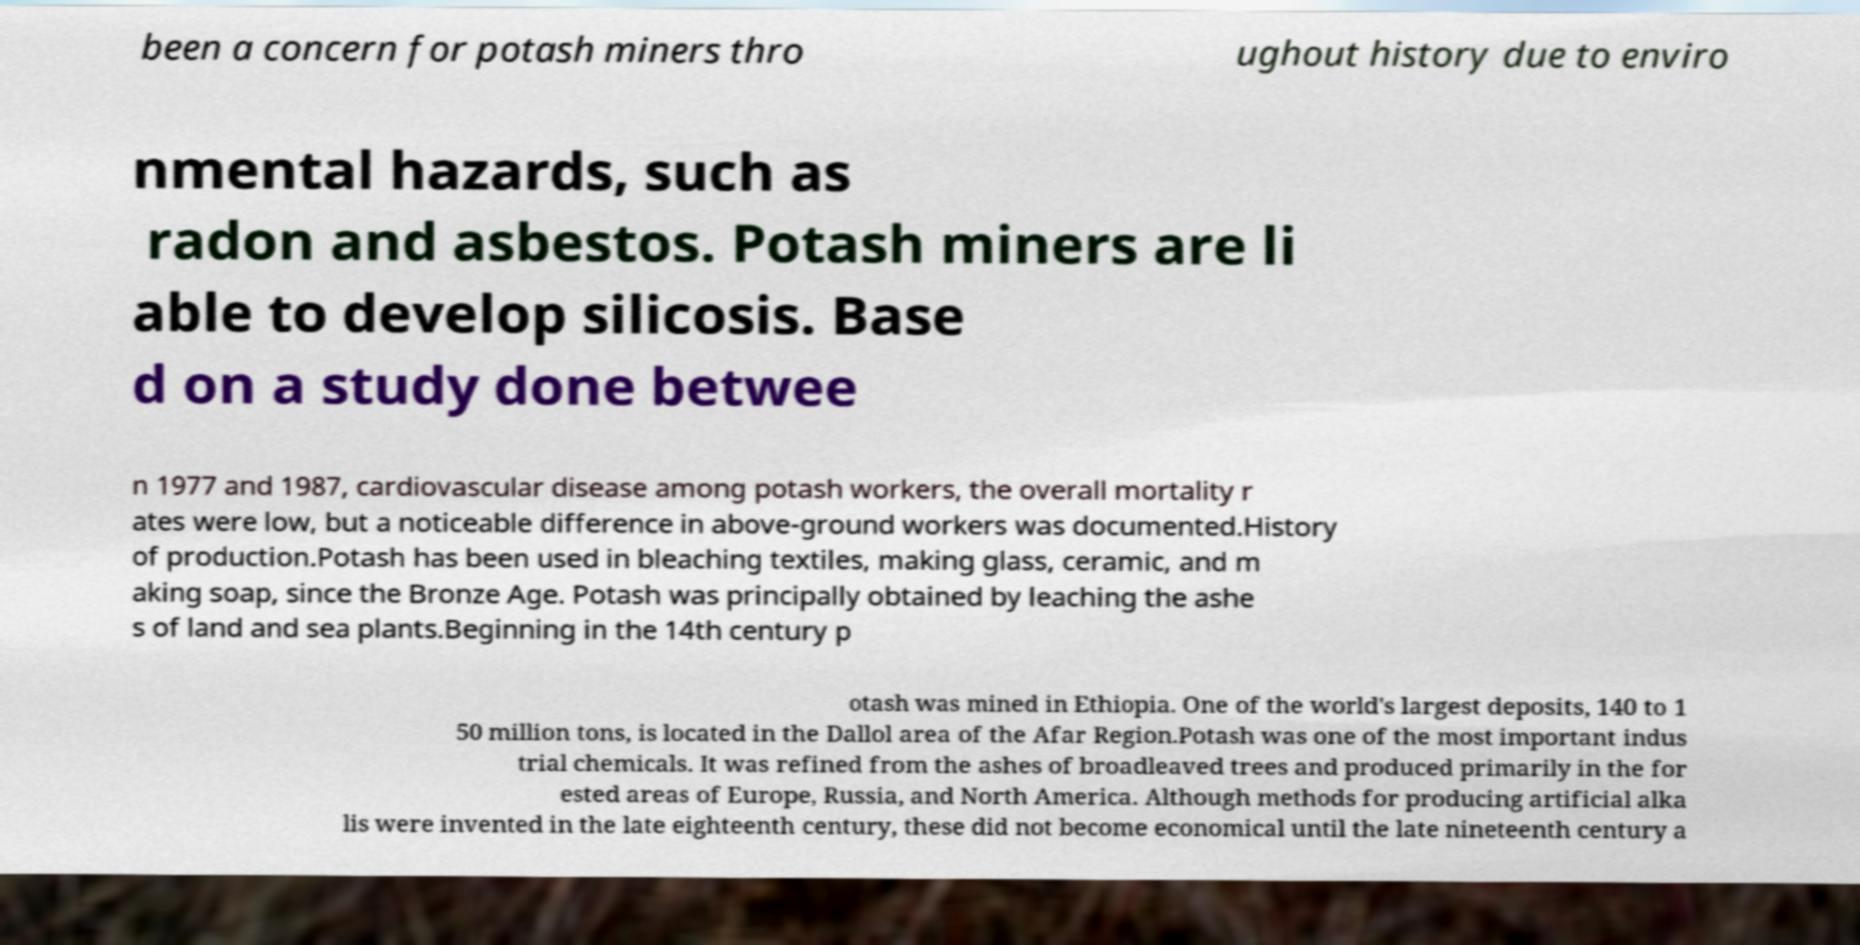Please identify and transcribe the text found in this image. been a concern for potash miners thro ughout history due to enviro nmental hazards, such as radon and asbestos. Potash miners are li able to develop silicosis. Base d on a study done betwee n 1977 and 1987, cardiovascular disease among potash workers, the overall mortality r ates were low, but a noticeable difference in above-ground workers was documented.History of production.Potash has been used in bleaching textiles, making glass, ceramic, and m aking soap, since the Bronze Age. Potash was principally obtained by leaching the ashe s of land and sea plants.Beginning in the 14th century p otash was mined in Ethiopia. One of the world's largest deposits, 140 to 1 50 million tons, is located in the Dallol area of the Afar Region.Potash was one of the most important indus trial chemicals. It was refined from the ashes of broadleaved trees and produced primarily in the for ested areas of Europe, Russia, and North America. Although methods for producing artificial alka lis were invented in the late eighteenth century, these did not become economical until the late nineteenth century a 